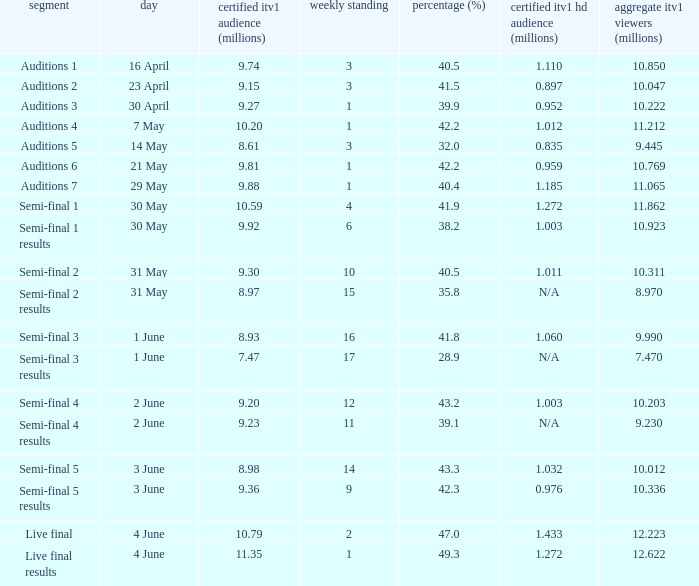When was the episode that had a share (%) of 41.5? 23 April. 